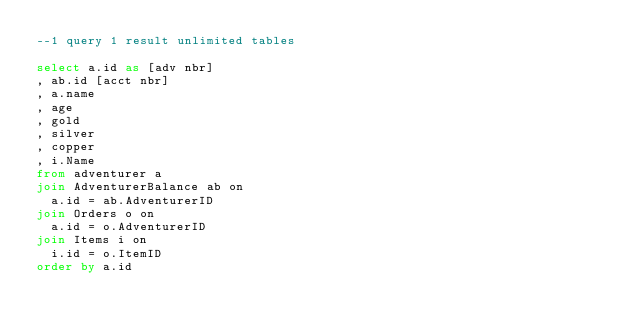<code> <loc_0><loc_0><loc_500><loc_500><_SQL_>--1 query 1 result unlimited tables

select a.id as [adv nbr]
, ab.id [acct nbr]
, a.name
, age
, gold
, silver
, copper
, i.Name
from adventurer a
join AdventurerBalance ab on 
	a.id = ab.AdventurerID
join Orders o on
	a.id = o.AdventurerID
join Items i on
	i.id = o.ItemID
order by a.id</code> 